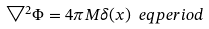Convert formula to latex. <formula><loc_0><loc_0><loc_500><loc_500>\bigtriangledown ^ { 2 } \Phi = 4 \pi M \delta ( x ) \ e q p e r i o d</formula> 